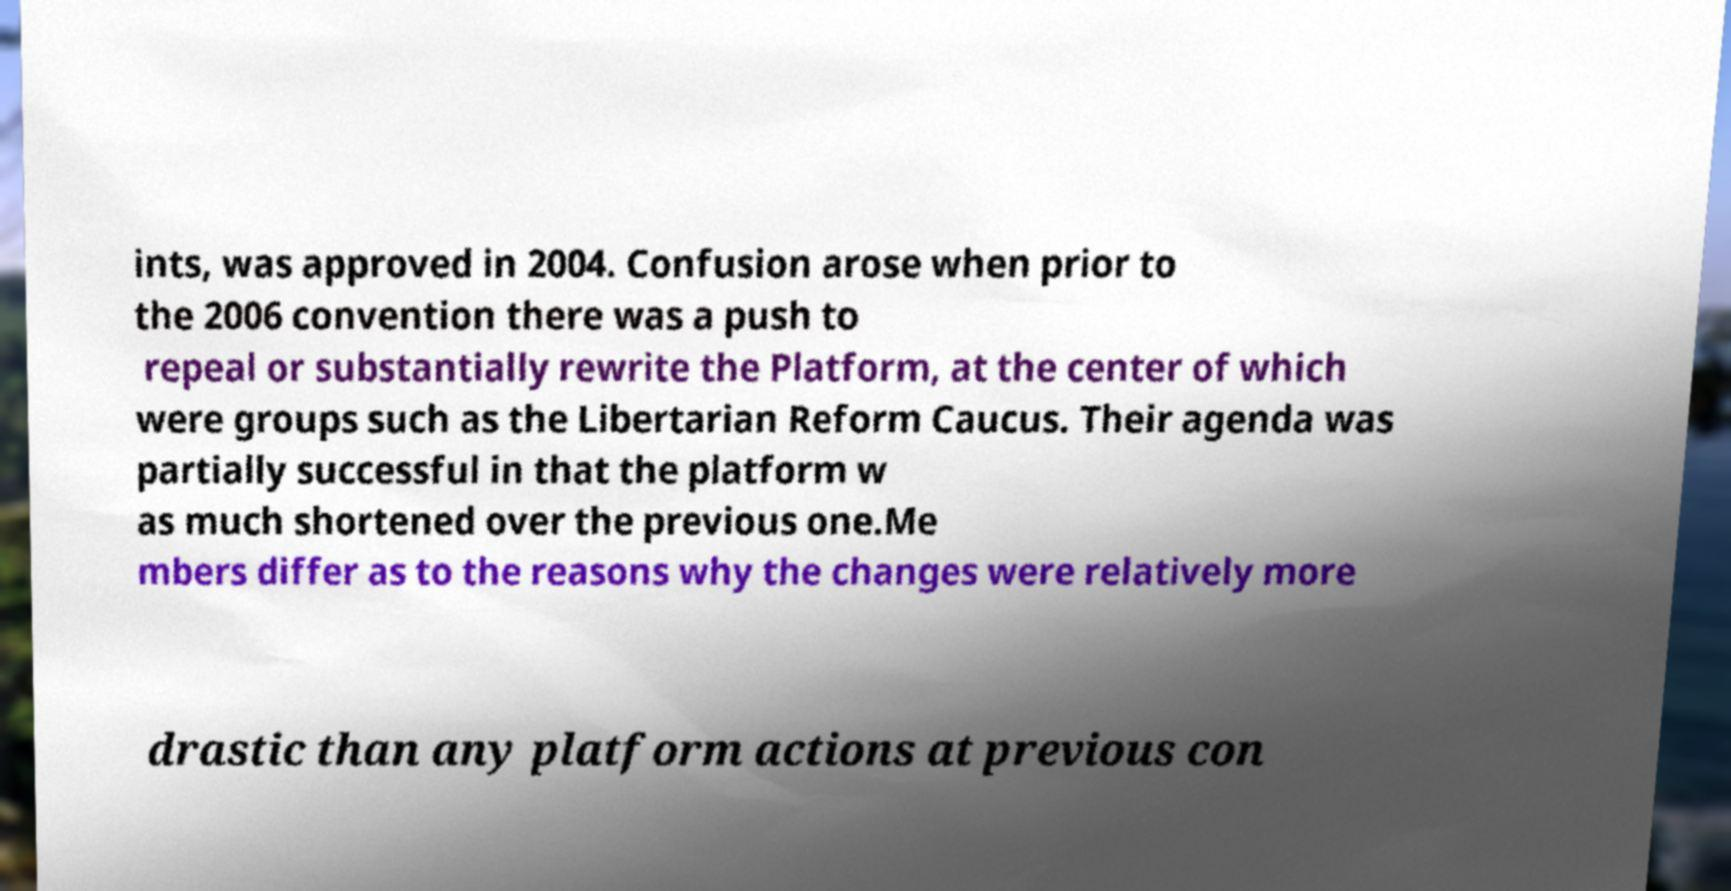Could you assist in decoding the text presented in this image and type it out clearly? ints, was approved in 2004. Confusion arose when prior to the 2006 convention there was a push to repeal or substantially rewrite the Platform, at the center of which were groups such as the Libertarian Reform Caucus. Their agenda was partially successful in that the platform w as much shortened over the previous one.Me mbers differ as to the reasons why the changes were relatively more drastic than any platform actions at previous con 